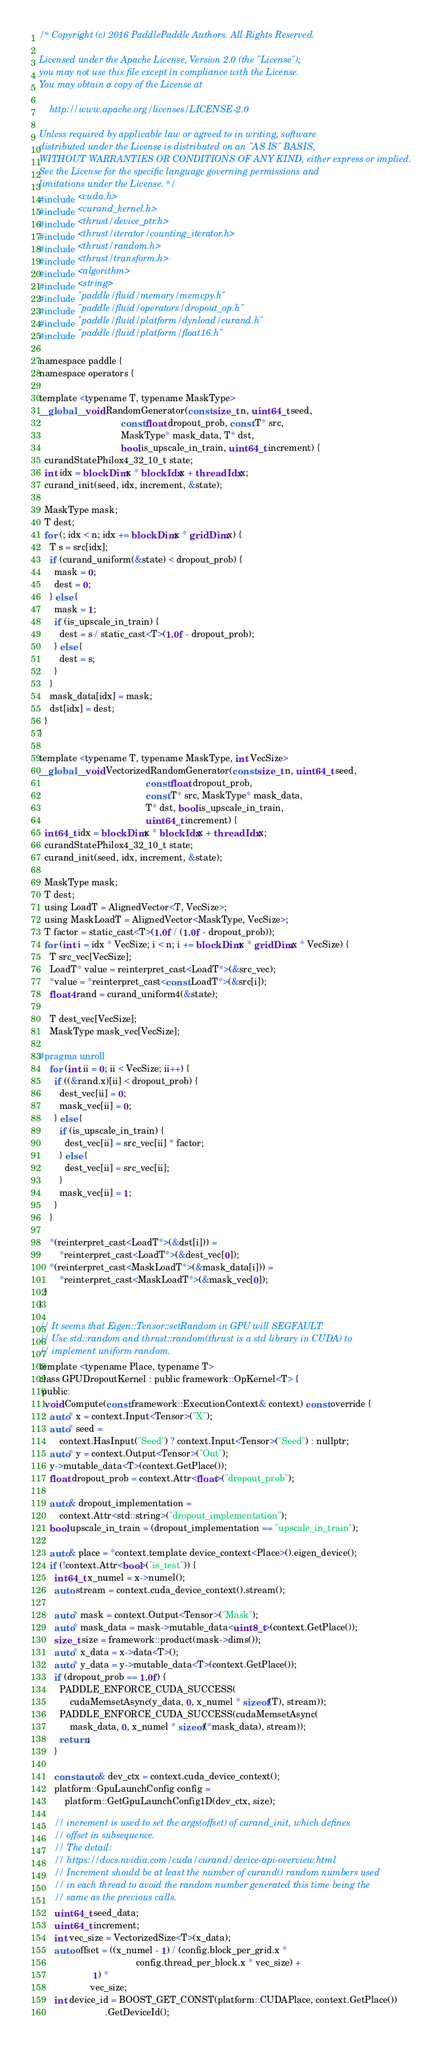Convert code to text. <code><loc_0><loc_0><loc_500><loc_500><_Cuda_>/* Copyright (c) 2016 PaddlePaddle Authors. All Rights Reserved.

Licensed under the Apache License, Version 2.0 (the "License");
you may not use this file except in compliance with the License.
You may obtain a copy of the License at

    http://www.apache.org/licenses/LICENSE-2.0

Unless required by applicable law or agreed to in writing, software
distributed under the License is distributed on an "AS IS" BASIS,
WITHOUT WARRANTIES OR CONDITIONS OF ANY KIND, either express or implied.
See the License for the specific language governing permissions and
limitations under the License. */
#include <cuda.h>
#include <curand_kernel.h>
#include <thrust/device_ptr.h>
#include <thrust/iterator/counting_iterator.h>
#include <thrust/random.h>
#include <thrust/transform.h>
#include <algorithm>
#include <string>
#include "paddle/fluid/memory/memcpy.h"
#include "paddle/fluid/operators/dropout_op.h"
#include "paddle/fluid/platform/dynload/curand.h"
#include "paddle/fluid/platform/float16.h"

namespace paddle {
namespace operators {

template <typename T, typename MaskType>
__global__ void RandomGenerator(const size_t n, uint64_t seed,
                                const float dropout_prob, const T* src,
                                MaskType* mask_data, T* dst,
                                bool is_upscale_in_train, uint64_t increment) {
  curandStatePhilox4_32_10_t state;
  int idx = blockDim.x * blockIdx.x + threadIdx.x;
  curand_init(seed, idx, increment, &state);

  MaskType mask;
  T dest;
  for (; idx < n; idx += blockDim.x * gridDim.x) {
    T s = src[idx];
    if (curand_uniform(&state) < dropout_prob) {
      mask = 0;
      dest = 0;
    } else {
      mask = 1;
      if (is_upscale_in_train) {
        dest = s / static_cast<T>(1.0f - dropout_prob);
      } else {
        dest = s;
      }
    }
    mask_data[idx] = mask;
    dst[idx] = dest;
  }
}

template <typename T, typename MaskType, int VecSize>
__global__ void VectorizedRandomGenerator(const size_t n, uint64_t seed,
                                          const float dropout_prob,
                                          const T* src, MaskType* mask_data,
                                          T* dst, bool is_upscale_in_train,
                                          uint64_t increment) {
  int64_t idx = blockDim.x * blockIdx.x + threadIdx.x;
  curandStatePhilox4_32_10_t state;
  curand_init(seed, idx, increment, &state);

  MaskType mask;
  T dest;
  using LoadT = AlignedVector<T, VecSize>;
  using MaskLoadT = AlignedVector<MaskType, VecSize>;
  T factor = static_cast<T>(1.0f / (1.0f - dropout_prob));
  for (int i = idx * VecSize; i < n; i += blockDim.x * gridDim.x * VecSize) {
    T src_vec[VecSize];
    LoadT* value = reinterpret_cast<LoadT*>(&src_vec);
    *value = *reinterpret_cast<const LoadT*>(&src[i]);
    float4 rand = curand_uniform4(&state);

    T dest_vec[VecSize];
    MaskType mask_vec[VecSize];

#pragma unroll
    for (int ii = 0; ii < VecSize; ii++) {
      if ((&rand.x)[ii] < dropout_prob) {
        dest_vec[ii] = 0;
        mask_vec[ii] = 0;
      } else {
        if (is_upscale_in_train) {
          dest_vec[ii] = src_vec[ii] * factor;
        } else {
          dest_vec[ii] = src_vec[ii];
        }
        mask_vec[ii] = 1;
      }
    }

    *(reinterpret_cast<LoadT*>(&dst[i])) =
        *reinterpret_cast<LoadT*>(&dest_vec[0]);
    *(reinterpret_cast<MaskLoadT*>(&mask_data[i])) =
        *reinterpret_cast<MaskLoadT*>(&mask_vec[0]);
  }
}

// It seems that Eigen::Tensor::setRandom in GPU will SEGFAULT.
// Use std::random and thrust::random(thrust is a std library in CUDA) to
// implement uniform random.
template <typename Place, typename T>
class GPUDropoutKernel : public framework::OpKernel<T> {
 public:
  void Compute(const framework::ExecutionContext& context) const override {
    auto* x = context.Input<Tensor>("X");
    auto* seed =
        context.HasInput("Seed") ? context.Input<Tensor>("Seed") : nullptr;
    auto* y = context.Output<Tensor>("Out");
    y->mutable_data<T>(context.GetPlace());
    float dropout_prob = context.Attr<float>("dropout_prob");

    auto& dropout_implementation =
        context.Attr<std::string>("dropout_implementation");
    bool upscale_in_train = (dropout_implementation == "upscale_in_train");

    auto& place = *context.template device_context<Place>().eigen_device();
    if (!context.Attr<bool>("is_test")) {
      int64_t x_numel = x->numel();
      auto stream = context.cuda_device_context().stream();

      auto* mask = context.Output<Tensor>("Mask");
      auto* mask_data = mask->mutable_data<uint8_t>(context.GetPlace());
      size_t size = framework::product(mask->dims());
      auto* x_data = x->data<T>();
      auto* y_data = y->mutable_data<T>(context.GetPlace());
      if (dropout_prob == 1.0f) {
        PADDLE_ENFORCE_CUDA_SUCCESS(
            cudaMemsetAsync(y_data, 0, x_numel * sizeof(T), stream));
        PADDLE_ENFORCE_CUDA_SUCCESS(cudaMemsetAsync(
            mask_data, 0, x_numel * sizeof(*mask_data), stream));
        return;
      }

      const auto& dev_ctx = context.cuda_device_context();
      platform::GpuLaunchConfig config =
          platform::GetGpuLaunchConfig1D(dev_ctx, size);

      // increment is used to set the args(offset) of curand_init, which defines
      // offset in subsequence.
      // The detail:
      // https://docs.nvidia.com/cuda/curand/device-api-overview.html
      // Increment should be at least the number of curand() random numbers used
      // in each thread to avoid the random number generated this time being the
      // same as the previous calls.
      uint64_t seed_data;
      uint64_t increment;
      int vec_size = VectorizedSize<T>(x_data);
      auto offset = ((x_numel - 1) / (config.block_per_grid.x *
                                      config.thread_per_block.x * vec_size) +
                     1) *
                    vec_size;
      int device_id = BOOST_GET_CONST(platform::CUDAPlace, context.GetPlace())
                          .GetDeviceId();</code> 